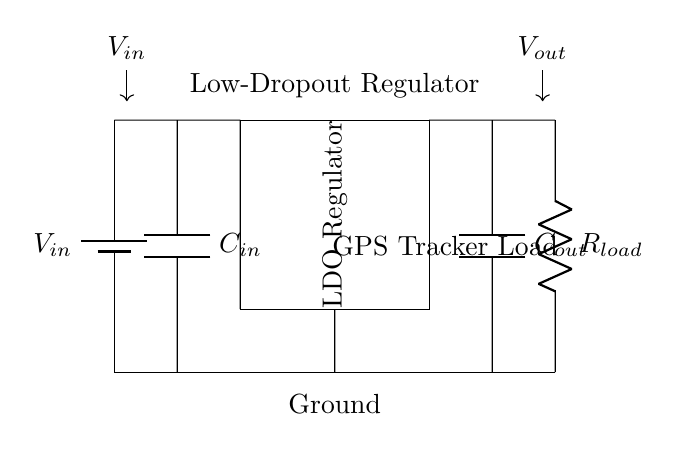What is the input voltage denoted in the circuit? The input voltage is labeled as V-in on the circuit diagram, where a battery symbol indicates the power source.
Answer: V-in What are the two main types of capacitors present in the circuit? The circuit includes two capacitors: one labeled C-in, connected directly to the input, and another labeled C-out, connected at the output of the LDO regulator.
Answer: C-in and C-out What is the purpose of the LDO regulator in the circuit? The LDO regulator is used to maintain a stable output voltage, allowing for a lower input voltage, which is essential in powering devices like GPS trackers efficiently.
Answer: Stable output voltage Which component limits the current going to the GPS tracker load? The component that limits the current is labeled R-load, indicating it is a resistor providing load resistance in the circuit while allowing current to flow to the GPS tracker load.
Answer: R-load How many connections are made to ground in this circuit? There are two connections to ground: one from the negative terminal of the battery and another from the LDO regulator through a direct line.
Answer: Two What type of regulator is depicted in this circuit? The circuit shows a low-dropout regulator, which is specifically designed to provide output voltage close to the input voltage, minimizing power loss, especially relevant for portable devices like GPS trackers.
Answer: Low-dropout regulator What is the purpose of the output capacitor in the circuit? The output capacitor, labeled C-out, helps stabilize the output voltage and smoothens any fluctuations caused by the load, ensuring consistent performance for the GPS tracker.
Answer: Stabilization of output voltage 